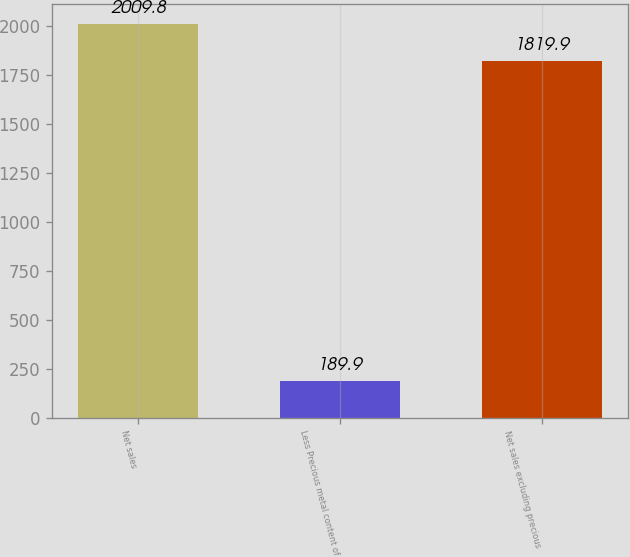<chart> <loc_0><loc_0><loc_500><loc_500><bar_chart><fcel>Net sales<fcel>Less Precious metal content of<fcel>Net sales excluding precious<nl><fcel>2009.8<fcel>189.9<fcel>1819.9<nl></chart> 